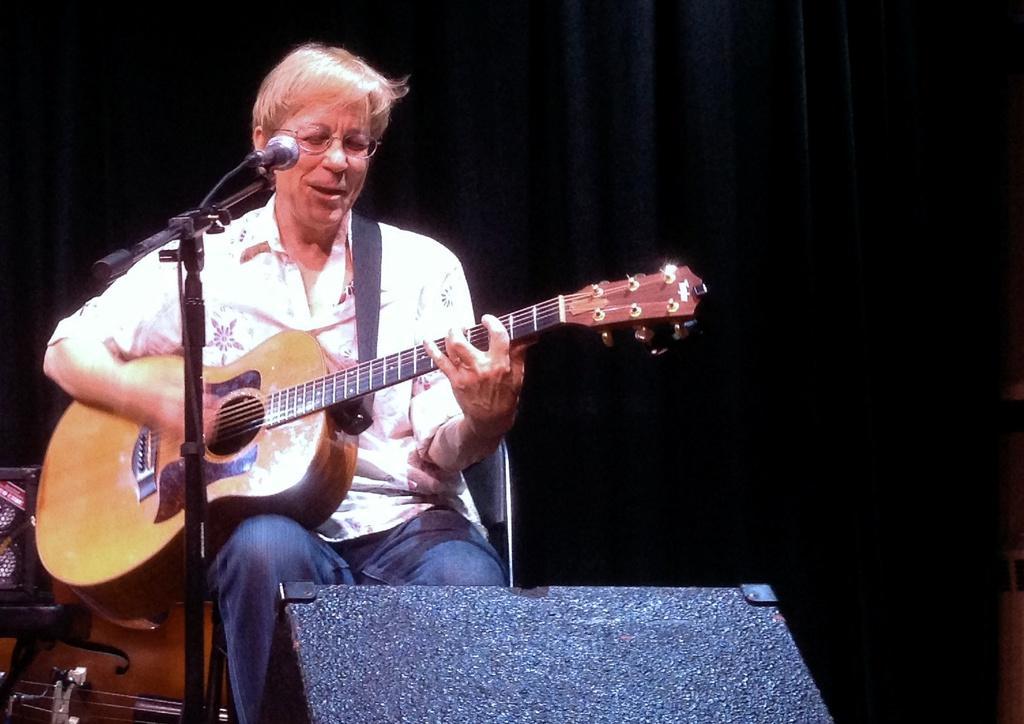How would you summarize this image in a sentence or two? A woman is playing guitar and there is a mic with stand. 